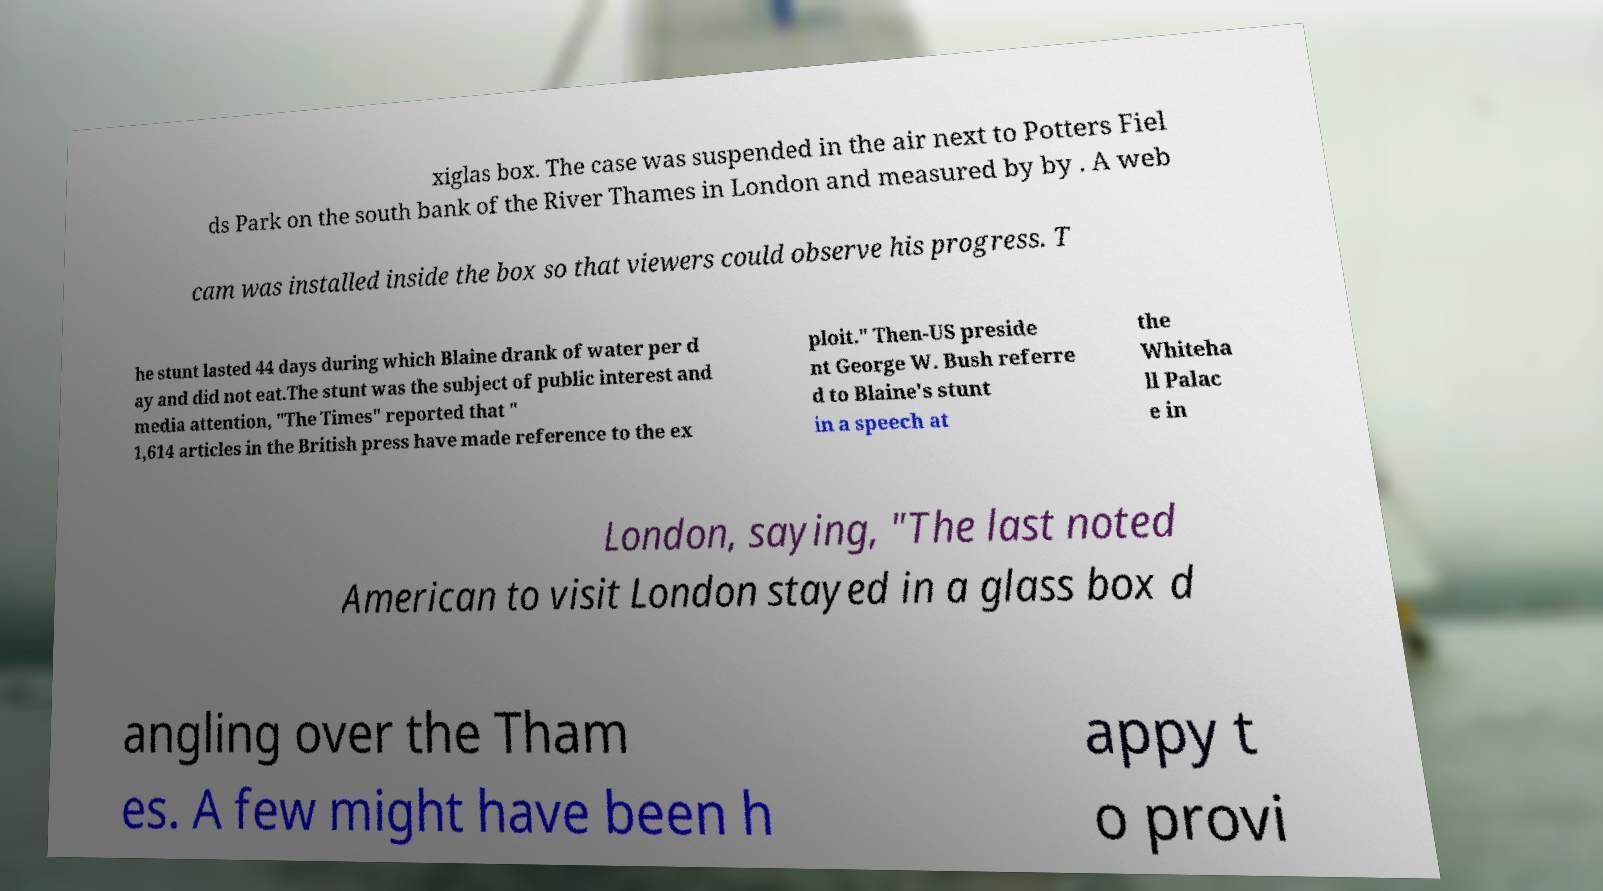Can you read and provide the text displayed in the image?This photo seems to have some interesting text. Can you extract and type it out for me? xiglas box. The case was suspended in the air next to Potters Fiel ds Park on the south bank of the River Thames in London and measured by by . A web cam was installed inside the box so that viewers could observe his progress. T he stunt lasted 44 days during which Blaine drank of water per d ay and did not eat.The stunt was the subject of public interest and media attention, "The Times" reported that " 1,614 articles in the British press have made reference to the ex ploit." Then-US preside nt George W. Bush referre d to Blaine's stunt in a speech at the Whiteha ll Palac e in London, saying, "The last noted American to visit London stayed in a glass box d angling over the Tham es. A few might have been h appy t o provi 